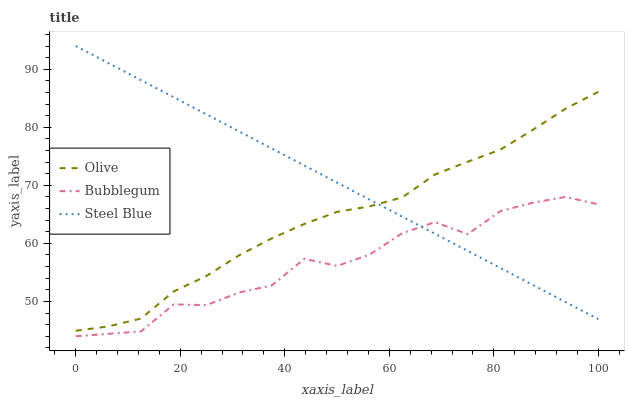Does Steel Blue have the minimum area under the curve?
Answer yes or no. No. Does Bubblegum have the maximum area under the curve?
Answer yes or no. No. Is Bubblegum the smoothest?
Answer yes or no. No. Is Steel Blue the roughest?
Answer yes or no. No. Does Steel Blue have the lowest value?
Answer yes or no. No. Does Bubblegum have the highest value?
Answer yes or no. No. Is Bubblegum less than Olive?
Answer yes or no. Yes. Is Olive greater than Bubblegum?
Answer yes or no. Yes. Does Bubblegum intersect Olive?
Answer yes or no. No. 